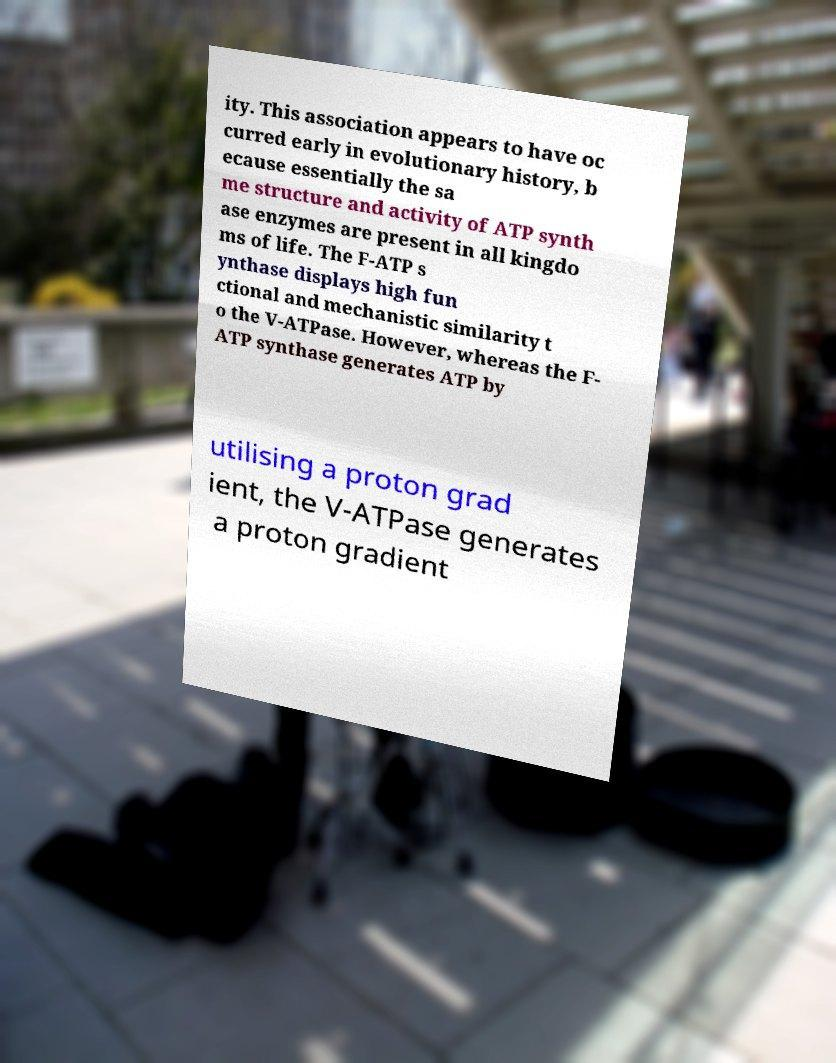For documentation purposes, I need the text within this image transcribed. Could you provide that? ity. This association appears to have oc curred early in evolutionary history, b ecause essentially the sa me structure and activity of ATP synth ase enzymes are present in all kingdo ms of life. The F-ATP s ynthase displays high fun ctional and mechanistic similarity t o the V-ATPase. However, whereas the F- ATP synthase generates ATP by utilising a proton grad ient, the V-ATPase generates a proton gradient 